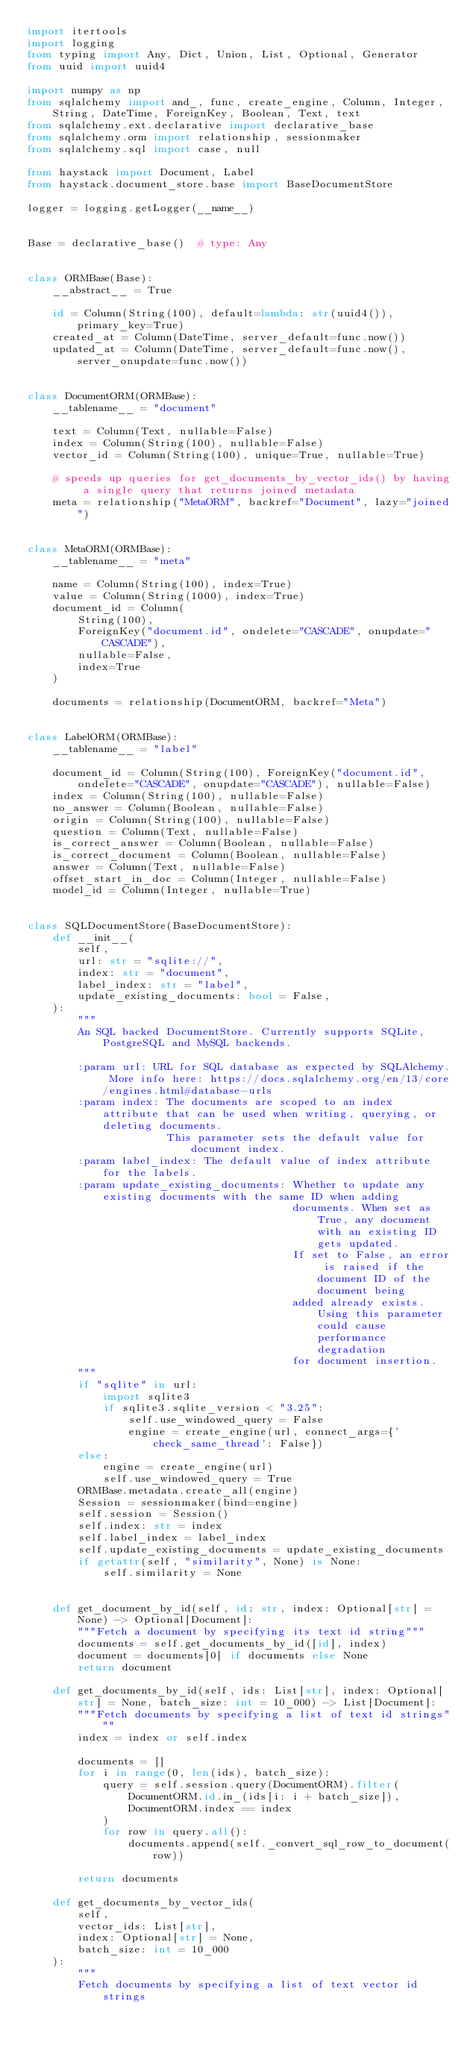<code> <loc_0><loc_0><loc_500><loc_500><_Python_>import itertools
import logging
from typing import Any, Dict, Union, List, Optional, Generator
from uuid import uuid4

import numpy as np
from sqlalchemy import and_, func, create_engine, Column, Integer, String, DateTime, ForeignKey, Boolean, Text, text
from sqlalchemy.ext.declarative import declarative_base
from sqlalchemy.orm import relationship, sessionmaker
from sqlalchemy.sql import case, null

from haystack import Document, Label
from haystack.document_store.base import BaseDocumentStore

logger = logging.getLogger(__name__)


Base = declarative_base()  # type: Any


class ORMBase(Base):
    __abstract__ = True

    id = Column(String(100), default=lambda: str(uuid4()), primary_key=True)
    created_at = Column(DateTime, server_default=func.now())
    updated_at = Column(DateTime, server_default=func.now(), server_onupdate=func.now())


class DocumentORM(ORMBase):
    __tablename__ = "document"

    text = Column(Text, nullable=False)
    index = Column(String(100), nullable=False)
    vector_id = Column(String(100), unique=True, nullable=True)

    # speeds up queries for get_documents_by_vector_ids() by having a single query that returns joined metadata
    meta = relationship("MetaORM", backref="Document", lazy="joined")


class MetaORM(ORMBase):
    __tablename__ = "meta"

    name = Column(String(100), index=True)
    value = Column(String(1000), index=True)
    document_id = Column(
        String(100),
        ForeignKey("document.id", ondelete="CASCADE", onupdate="CASCADE"),
        nullable=False,
        index=True
    )

    documents = relationship(DocumentORM, backref="Meta")


class LabelORM(ORMBase):
    __tablename__ = "label"

    document_id = Column(String(100), ForeignKey("document.id", ondelete="CASCADE", onupdate="CASCADE"), nullable=False)
    index = Column(String(100), nullable=False)
    no_answer = Column(Boolean, nullable=False)
    origin = Column(String(100), nullable=False)
    question = Column(Text, nullable=False)
    is_correct_answer = Column(Boolean, nullable=False)
    is_correct_document = Column(Boolean, nullable=False)
    answer = Column(Text, nullable=False)
    offset_start_in_doc = Column(Integer, nullable=False)
    model_id = Column(Integer, nullable=True)


class SQLDocumentStore(BaseDocumentStore):
    def __init__(
        self,
        url: str = "sqlite://",
        index: str = "document",
        label_index: str = "label",
        update_existing_documents: bool = False,
    ):
        """
        An SQL backed DocumentStore. Currently supports SQLite, PostgreSQL and MySQL backends.

        :param url: URL for SQL database as expected by SQLAlchemy. More info here: https://docs.sqlalchemy.org/en/13/core/engines.html#database-urls
        :param index: The documents are scoped to an index attribute that can be used when writing, querying, or deleting documents. 
                      This parameter sets the default value for document index.
        :param label_index: The default value of index attribute for the labels.
        :param update_existing_documents: Whether to update any existing documents with the same ID when adding
                                          documents. When set as True, any document with an existing ID gets updated.
                                          If set to False, an error is raised if the document ID of the document being
                                          added already exists. Using this parameter could cause performance degradation
                                          for document insertion.
        """
        if "sqlite" in url:
            import sqlite3
            if sqlite3.sqlite_version < "3.25":
                self.use_windowed_query = False
                engine = create_engine(url, connect_args={'check_same_thread': False})
        else:
            engine = create_engine(url)
            self.use_windowed_query = True
        ORMBase.metadata.create_all(engine)
        Session = sessionmaker(bind=engine)
        self.session = Session()
        self.index: str = index
        self.label_index = label_index
        self.update_existing_documents = update_existing_documents
        if getattr(self, "similarity", None) is None:
            self.similarity = None
        

    def get_document_by_id(self, id: str, index: Optional[str] = None) -> Optional[Document]:
        """Fetch a document by specifying its text id string"""
        documents = self.get_documents_by_id([id], index)
        document = documents[0] if documents else None
        return document

    def get_documents_by_id(self, ids: List[str], index: Optional[str] = None, batch_size: int = 10_000) -> List[Document]:
        """Fetch documents by specifying a list of text id strings"""
        index = index or self.index

        documents = []
        for i in range(0, len(ids), batch_size):
            query = self.session.query(DocumentORM).filter(
                DocumentORM.id.in_(ids[i: i + batch_size]),
                DocumentORM.index == index
            )
            for row in query.all():
                documents.append(self._convert_sql_row_to_document(row))

        return documents

    def get_documents_by_vector_ids(
        self,
        vector_ids: List[str],
        index: Optional[str] = None,
        batch_size: int = 10_000
    ):
        """
        Fetch documents by specifying a list of text vector id strings
</code> 